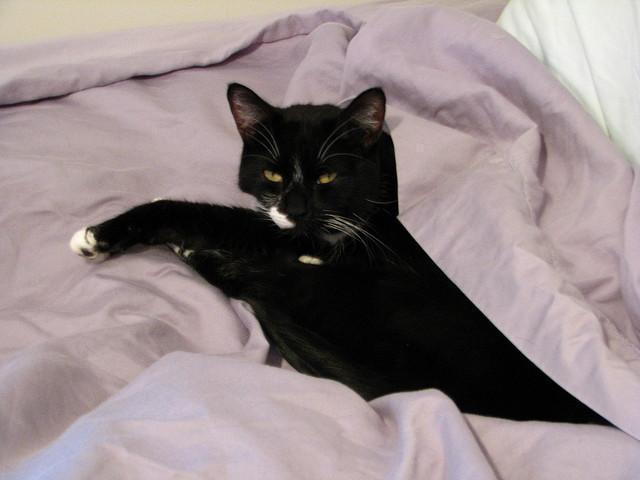How many white cars are on the road?
Give a very brief answer. 0. 